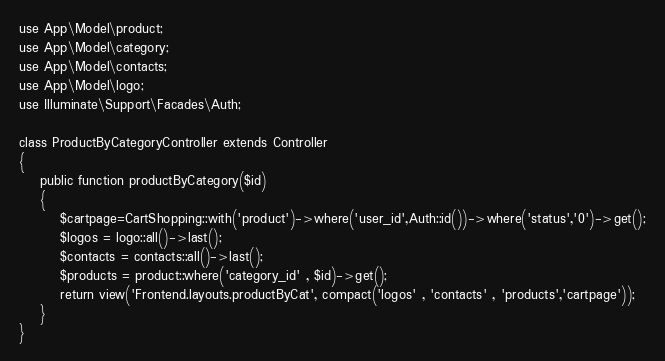<code> <loc_0><loc_0><loc_500><loc_500><_PHP_>use App\Model\product;
use App\Model\category;
use App\Model\contacts;
use App\Model\logo;
use Illuminate\Support\Facades\Auth;

class ProductByCategoryController extends Controller
{
    public function productByCategory($id)
    {
        $cartpage=CartShopping::with('product')->where('user_id',Auth::id())->where('status','0')->get();
        $logos = logo::all()->last();
        $contacts = contacts::all()->last();
        $products = product::where('category_id' , $id)->get();
        return view('Frontend.layouts.productByCat', compact('logos' , 'contacts' , 'products','cartpage'));
    }
}
</code> 